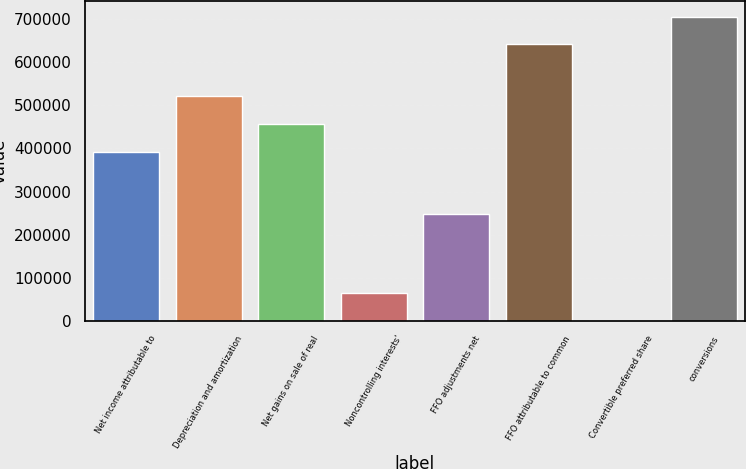Convert chart. <chart><loc_0><loc_0><loc_500><loc_500><bar_chart><fcel>Net income attributable to<fcel>Depreciation and amortization<fcel>Net gains on sale of real<fcel>Noncontrolling interests'<fcel>FFO adjustments net<fcel>FFO attributable to common<fcel>Convertible preferred share<fcel>conversions<nl><fcel>392034<fcel>520220<fcel>456127<fcel>64200.9<fcel>248895<fcel>640929<fcel>108<fcel>705022<nl></chart> 